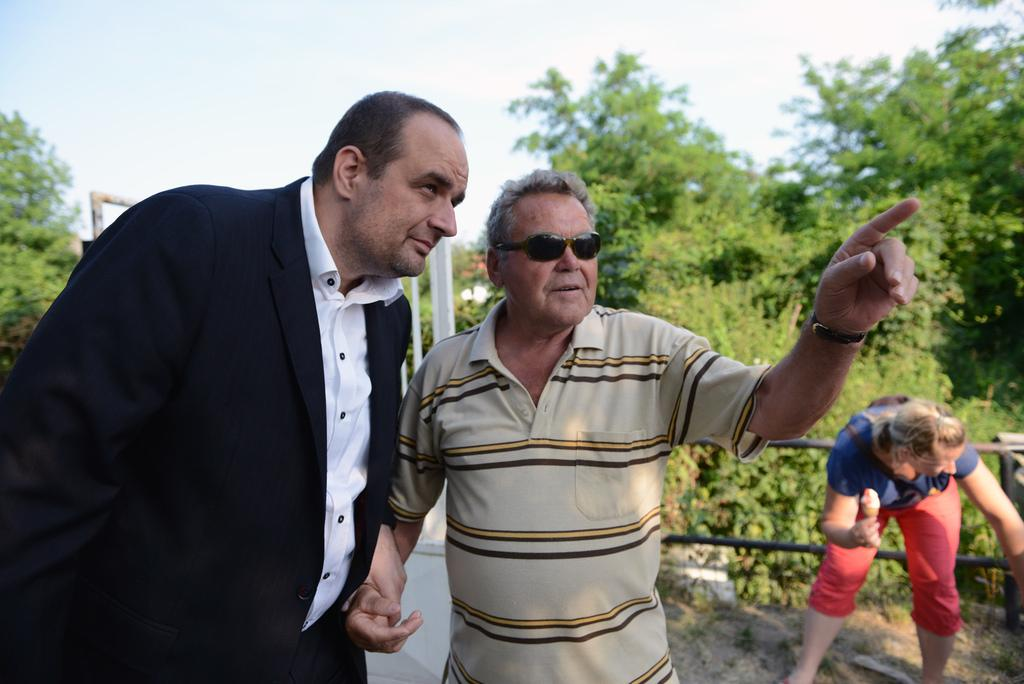What are the people in the image doing? The people in the image are standing. What is the woman holding in her hand? The woman is holding an ice cream in her hand. What can be seen in the background of the image? There are trees visible in the background of the image. How would you describe the weather in the image? The sky is cloudy in the image, suggesting a potentially overcast or rainy day. Where is the bat hanging from in the image? There is no bat present in the image. What type of popcorn is being served at the event in the image? There is no event or popcorn present in the image. 